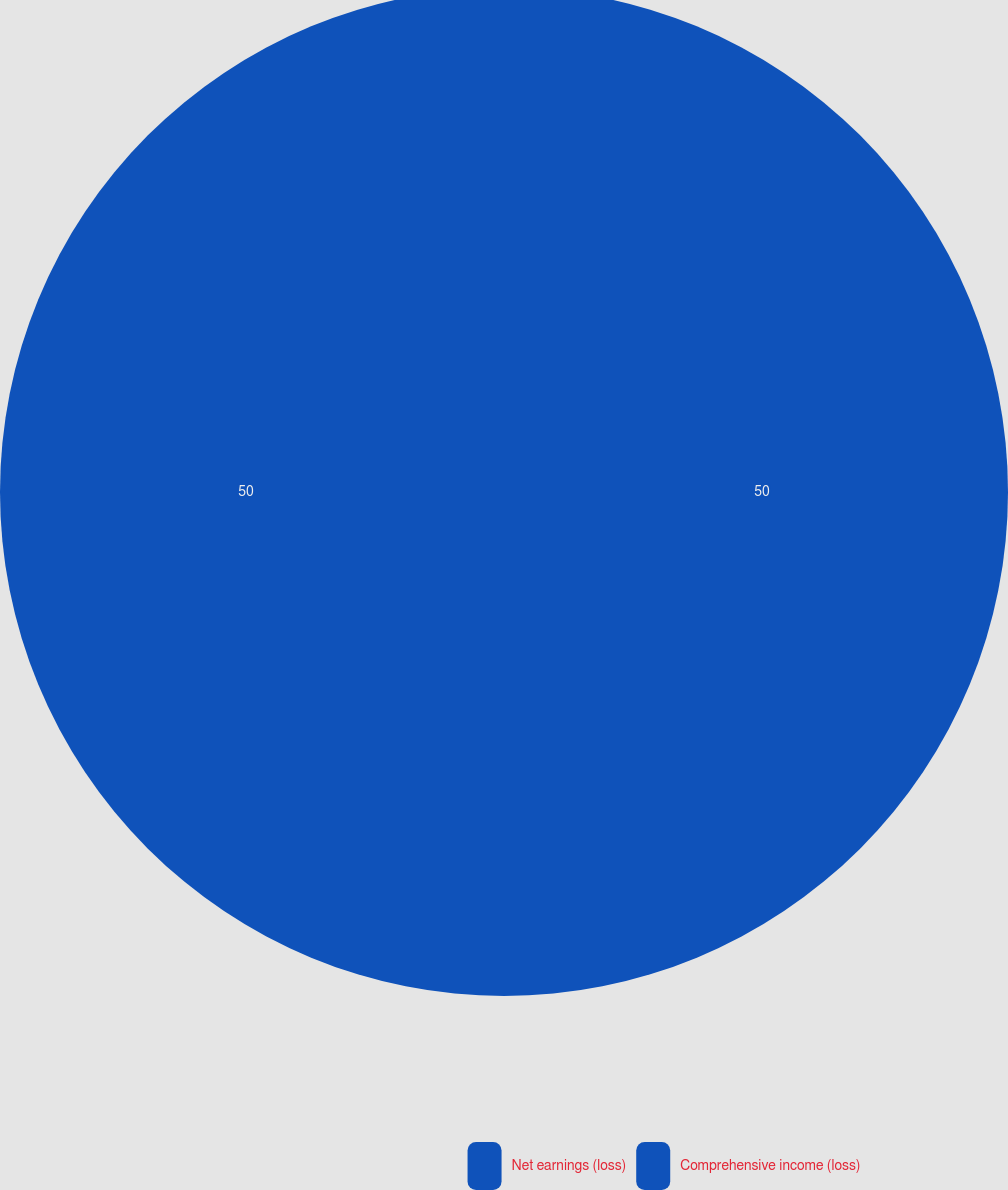Convert chart. <chart><loc_0><loc_0><loc_500><loc_500><pie_chart><fcel>Net earnings (loss)<fcel>Comprehensive income (loss)<nl><fcel>50.0%<fcel>50.0%<nl></chart> 